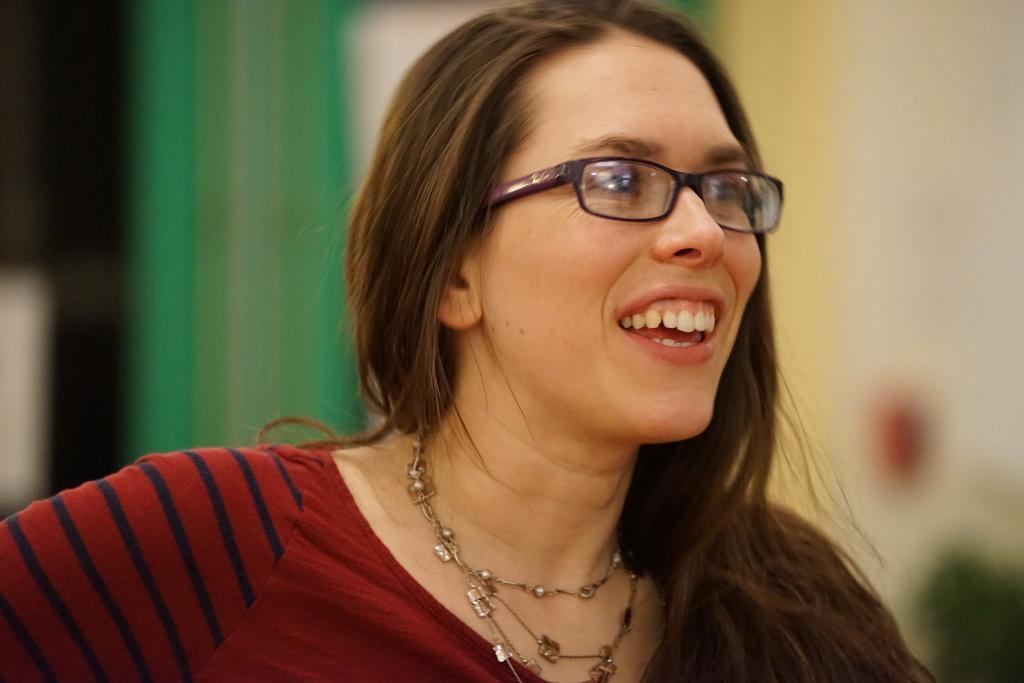In one or two sentences, can you explain what this image depicts? In this image there is a girl who is smiling. The girl is having the spectacles. The woman is wearing the red dress and a chain to her neck. 